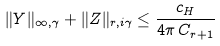Convert formula to latex. <formula><loc_0><loc_0><loc_500><loc_500>\| Y \| _ { \infty , \gamma } + \| Z \| _ { r , i \gamma } \leq \frac { c _ { H } } { 4 \pi \, C _ { r + 1 } }</formula> 